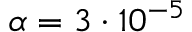Convert formula to latex. <formula><loc_0><loc_0><loc_500><loc_500>\alpha = 3 \cdot 1 0 ^ { - 5 }</formula> 